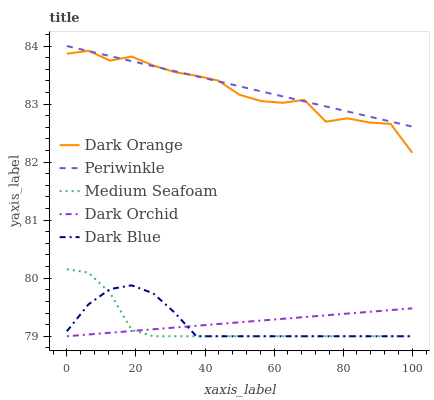Does Medium Seafoam have the minimum area under the curve?
Answer yes or no. Yes. Does Periwinkle have the maximum area under the curve?
Answer yes or no. Yes. Does Periwinkle have the minimum area under the curve?
Answer yes or no. No. Does Medium Seafoam have the maximum area under the curve?
Answer yes or no. No. Is Dark Orchid the smoothest?
Answer yes or no. Yes. Is Dark Orange the roughest?
Answer yes or no. Yes. Is Periwinkle the smoothest?
Answer yes or no. No. Is Periwinkle the roughest?
Answer yes or no. No. Does Medium Seafoam have the lowest value?
Answer yes or no. Yes. Does Periwinkle have the lowest value?
Answer yes or no. No. Does Periwinkle have the highest value?
Answer yes or no. Yes. Does Medium Seafoam have the highest value?
Answer yes or no. No. Is Dark Orchid less than Periwinkle?
Answer yes or no. Yes. Is Dark Orange greater than Medium Seafoam?
Answer yes or no. Yes. Does Dark Blue intersect Dark Orchid?
Answer yes or no. Yes. Is Dark Blue less than Dark Orchid?
Answer yes or no. No. Is Dark Blue greater than Dark Orchid?
Answer yes or no. No. Does Dark Orchid intersect Periwinkle?
Answer yes or no. No. 